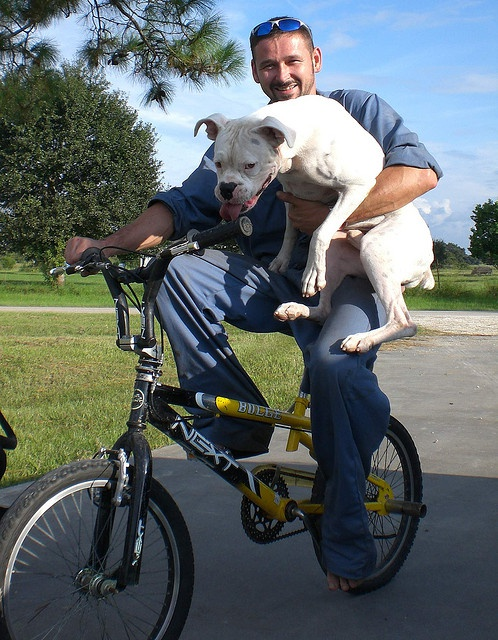Describe the objects in this image and their specific colors. I can see people in black, white, gray, and navy tones, bicycle in black, gray, and darkblue tones, and dog in black, white, gray, and darkgray tones in this image. 